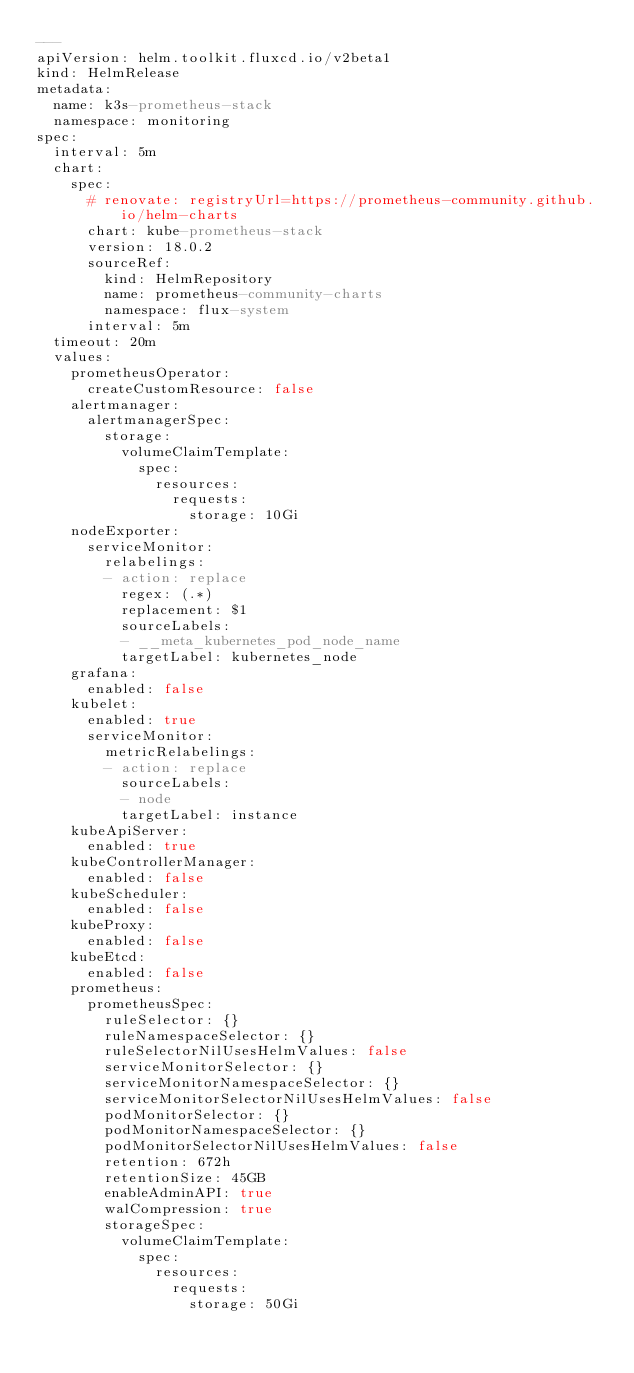Convert code to text. <code><loc_0><loc_0><loc_500><loc_500><_YAML_>---
apiVersion: helm.toolkit.fluxcd.io/v2beta1
kind: HelmRelease
metadata:
  name: k3s-prometheus-stack
  namespace: monitoring
spec:
  interval: 5m
  chart:
    spec:
      # renovate: registryUrl=https://prometheus-community.github.io/helm-charts
      chart: kube-prometheus-stack
      version: 18.0.2
      sourceRef:
        kind: HelmRepository
        name: prometheus-community-charts
        namespace: flux-system
      interval: 5m
  timeout: 20m
  values:
    prometheusOperator:
      createCustomResource: false
    alertmanager:
      alertmanagerSpec:
        storage:
          volumeClaimTemplate:
            spec:
              resources:
                requests:
                  storage: 10Gi
    nodeExporter:
      serviceMonitor:
        relabelings:
        - action: replace
          regex: (.*)
          replacement: $1
          sourceLabels:
          - __meta_kubernetes_pod_node_name
          targetLabel: kubernetes_node
    grafana:
      enabled: false
    kubelet:
      enabled: true
      serviceMonitor:
        metricRelabelings:
        - action: replace
          sourceLabels:
          - node
          targetLabel: instance
    kubeApiServer:
      enabled: true
    kubeControllerManager:
      enabled: false
    kubeScheduler:
      enabled: false
    kubeProxy:
      enabled: false
    kubeEtcd:
      enabled: false
    prometheus:
      prometheusSpec:
        ruleSelector: {}
        ruleNamespaceSelector: {}
        ruleSelectorNilUsesHelmValues: false
        serviceMonitorSelector: {}
        serviceMonitorNamespaceSelector: {}
        serviceMonitorSelectorNilUsesHelmValues: false
        podMonitorSelector: {}
        podMonitorNamespaceSelector: {}
        podMonitorSelectorNilUsesHelmValues: false
        retention: 672h
        retentionSize: 45GB
        enableAdminAPI: true
        walCompression: true
        storageSpec:
          volumeClaimTemplate:
            spec:
              resources:
                requests:
                  storage: 50Gi
</code> 